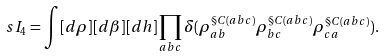Convert formula to latex. <formula><loc_0><loc_0><loc_500><loc_500>\ s I _ { 4 } = \int [ d \rho ] [ d \beta ] [ d h ] \prod _ { a b c } \delta ( \rho ^ { \S C ( a b c ) } _ { a b } \rho ^ { \S C ( a b c ) } _ { b c } \rho ^ { \S C ( a b c ) } _ { c a } ) .</formula> 